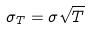Convert formula to latex. <formula><loc_0><loc_0><loc_500><loc_500>\sigma _ { T } = \sigma \sqrt { T }</formula> 